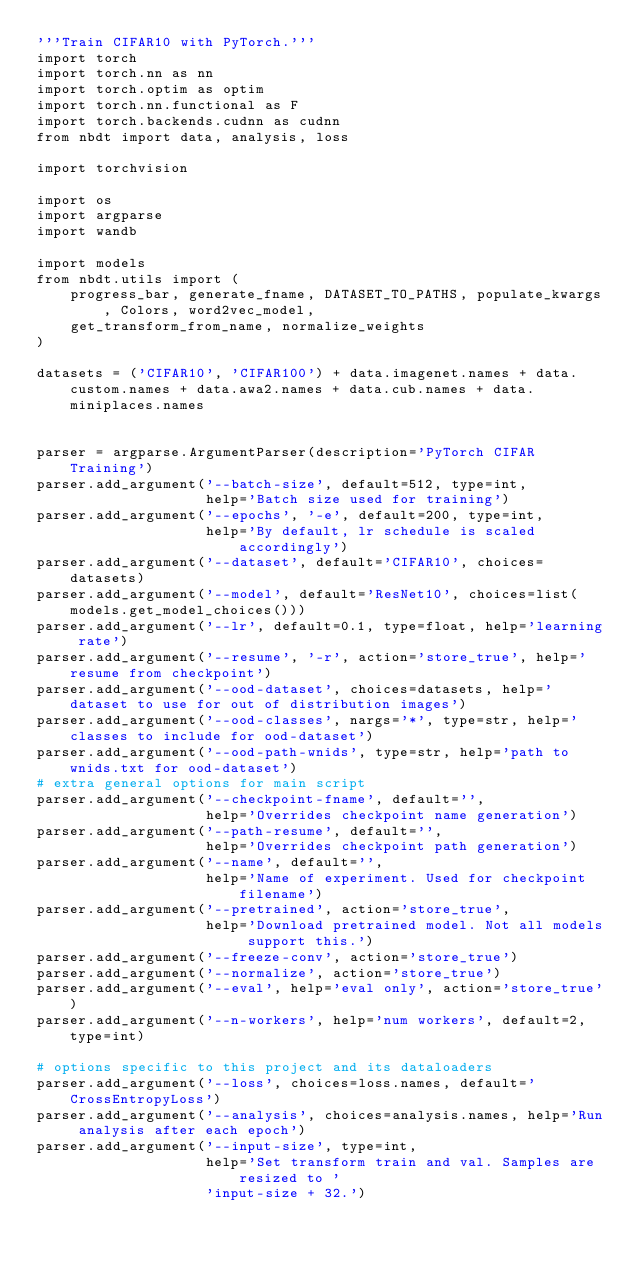<code> <loc_0><loc_0><loc_500><loc_500><_Python_>'''Train CIFAR10 with PyTorch.'''
import torch
import torch.nn as nn
import torch.optim as optim
import torch.nn.functional as F
import torch.backends.cudnn as cudnn
from nbdt import data, analysis, loss

import torchvision

import os
import argparse
import wandb

import models
from nbdt.utils import (
    progress_bar, generate_fname, DATASET_TO_PATHS, populate_kwargs, Colors, word2vec_model,
    get_transform_from_name, normalize_weights
)

datasets = ('CIFAR10', 'CIFAR100') + data.imagenet.names + data.custom.names + data.awa2.names + data.cub.names + data.miniplaces.names


parser = argparse.ArgumentParser(description='PyTorch CIFAR Training')
parser.add_argument('--batch-size', default=512, type=int,
                    help='Batch size used for training')
parser.add_argument('--epochs', '-e', default=200, type=int,
                    help='By default, lr schedule is scaled accordingly')
parser.add_argument('--dataset', default='CIFAR10', choices=datasets)
parser.add_argument('--model', default='ResNet10', choices=list(models.get_model_choices()))
parser.add_argument('--lr', default=0.1, type=float, help='learning rate')
parser.add_argument('--resume', '-r', action='store_true', help='resume from checkpoint')
parser.add_argument('--ood-dataset', choices=datasets, help='dataset to use for out of distribution images')
parser.add_argument('--ood-classes', nargs='*', type=str, help='classes to include for ood-dataset')
parser.add_argument('--ood-path-wnids', type=str, help='path to wnids.txt for ood-dataset')
# extra general options for main script
parser.add_argument('--checkpoint-fname', default='',
                    help='Overrides checkpoint name generation')
parser.add_argument('--path-resume', default='',
                    help='Overrides checkpoint path generation')
parser.add_argument('--name', default='',
                    help='Name of experiment. Used for checkpoint filename')
parser.add_argument('--pretrained', action='store_true',
                    help='Download pretrained model. Not all models support this.')
parser.add_argument('--freeze-conv', action='store_true')
parser.add_argument('--normalize', action='store_true')
parser.add_argument('--eval', help='eval only', action='store_true')
parser.add_argument('--n-workers', help='num workers', default=2, type=int)

# options specific to this project and its dataloaders
parser.add_argument('--loss', choices=loss.names, default='CrossEntropyLoss')
parser.add_argument('--analysis', choices=analysis.names, help='Run analysis after each epoch')
parser.add_argument('--input-size', type=int,
                    help='Set transform train and val. Samples are resized to '
                    'input-size + 32.')</code> 